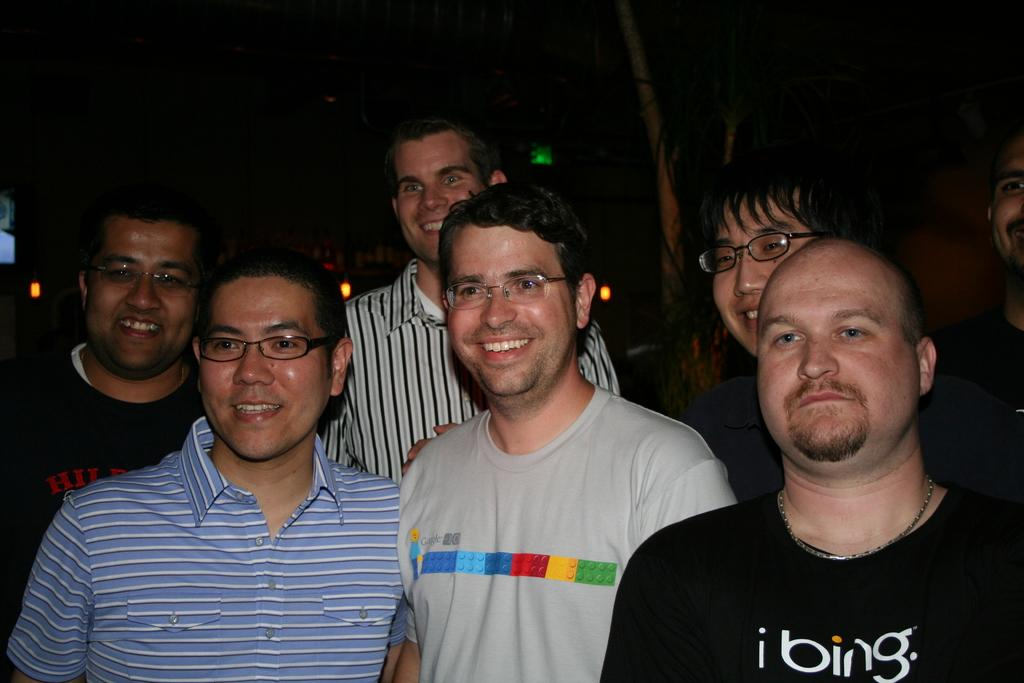Who or what can be seen in the image? There are people in the image. What is the color of the background in the image? The background of the image is dark. What can be seen in the distance in the image? There is a tree and lights visible in the background. What type of kitten can be seen climbing the tree in the image? There is no kitten present in the image, and therefore no such activity can be observed. 